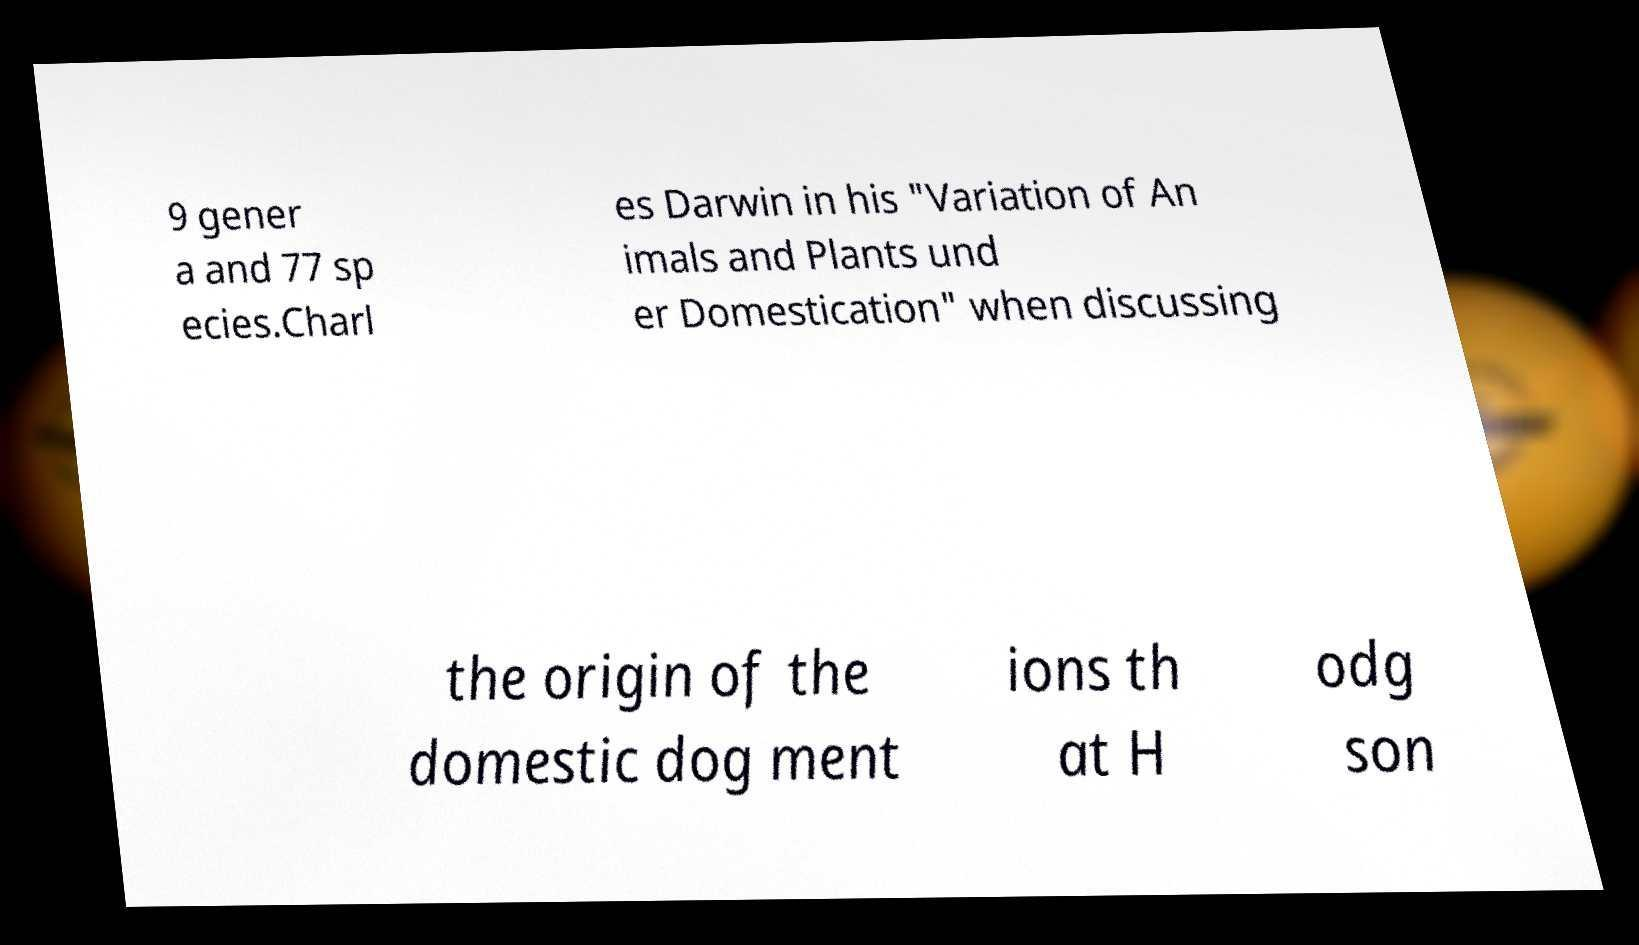Can you accurately transcribe the text from the provided image for me? 9 gener a and 77 sp ecies.Charl es Darwin in his "Variation of An imals and Plants und er Domestication" when discussing the origin of the domestic dog ment ions th at H odg son 